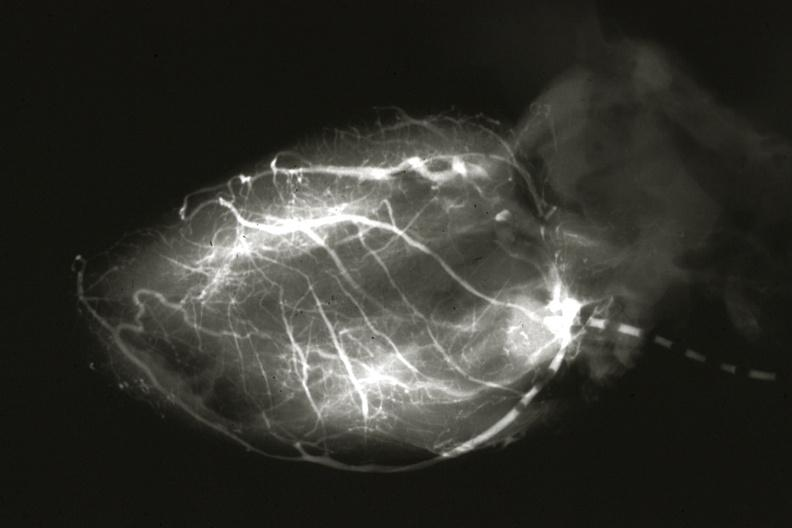s cardiovascular present?
Answer the question using a single word or phrase. Yes 